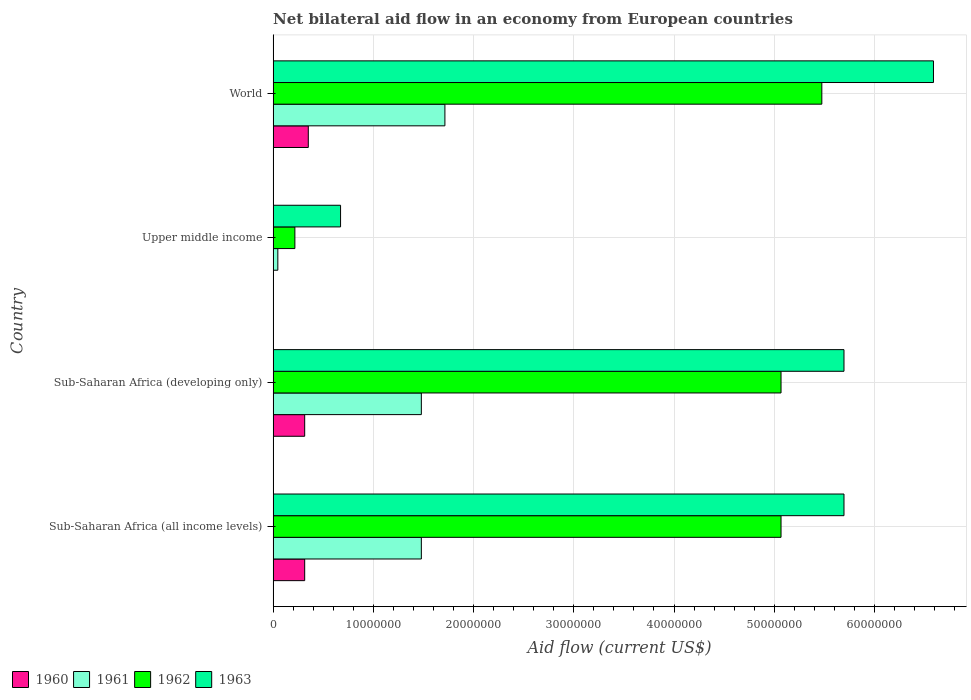How many different coloured bars are there?
Offer a very short reply. 4. Are the number of bars per tick equal to the number of legend labels?
Your answer should be compact. Yes. How many bars are there on the 4th tick from the bottom?
Provide a succinct answer. 4. What is the label of the 3rd group of bars from the top?
Ensure brevity in your answer.  Sub-Saharan Africa (developing only). In how many cases, is the number of bars for a given country not equal to the number of legend labels?
Provide a succinct answer. 0. What is the net bilateral aid flow in 1962 in World?
Give a very brief answer. 5.48e+07. Across all countries, what is the maximum net bilateral aid flow in 1961?
Make the answer very short. 1.71e+07. Across all countries, what is the minimum net bilateral aid flow in 1960?
Provide a short and direct response. 10000. In which country was the net bilateral aid flow in 1962 minimum?
Make the answer very short. Upper middle income. What is the total net bilateral aid flow in 1961 in the graph?
Make the answer very short. 4.72e+07. What is the difference between the net bilateral aid flow in 1961 in Sub-Saharan Africa (developing only) and that in World?
Make the answer very short. -2.35e+06. What is the difference between the net bilateral aid flow in 1963 in World and the net bilateral aid flow in 1961 in Upper middle income?
Your answer should be very brief. 6.54e+07. What is the average net bilateral aid flow in 1962 per country?
Give a very brief answer. 3.96e+07. What is the difference between the net bilateral aid flow in 1962 and net bilateral aid flow in 1960 in World?
Your answer should be very brief. 5.12e+07. What is the ratio of the net bilateral aid flow in 1963 in Sub-Saharan Africa (all income levels) to that in World?
Provide a succinct answer. 0.86. Is the difference between the net bilateral aid flow in 1962 in Sub-Saharan Africa (all income levels) and World greater than the difference between the net bilateral aid flow in 1960 in Sub-Saharan Africa (all income levels) and World?
Provide a short and direct response. No. What is the difference between the highest and the second highest net bilateral aid flow in 1962?
Make the answer very short. 4.07e+06. What is the difference between the highest and the lowest net bilateral aid flow in 1962?
Offer a very short reply. 5.26e+07. In how many countries, is the net bilateral aid flow in 1960 greater than the average net bilateral aid flow in 1960 taken over all countries?
Your answer should be very brief. 3. Is the sum of the net bilateral aid flow in 1961 in Sub-Saharan Africa (developing only) and World greater than the maximum net bilateral aid flow in 1963 across all countries?
Offer a terse response. No. What does the 2nd bar from the top in Sub-Saharan Africa (all income levels) represents?
Offer a terse response. 1962. What does the 3rd bar from the bottom in Sub-Saharan Africa (all income levels) represents?
Your answer should be compact. 1962. Are all the bars in the graph horizontal?
Give a very brief answer. Yes. How many countries are there in the graph?
Provide a short and direct response. 4. What is the difference between two consecutive major ticks on the X-axis?
Keep it short and to the point. 1.00e+07. Does the graph contain grids?
Offer a very short reply. Yes. How are the legend labels stacked?
Ensure brevity in your answer.  Horizontal. What is the title of the graph?
Your answer should be very brief. Net bilateral aid flow in an economy from European countries. Does "1996" appear as one of the legend labels in the graph?
Your answer should be compact. No. What is the Aid flow (current US$) of 1960 in Sub-Saharan Africa (all income levels)?
Your answer should be compact. 3.15e+06. What is the Aid flow (current US$) of 1961 in Sub-Saharan Africa (all income levels)?
Your answer should be very brief. 1.48e+07. What is the Aid flow (current US$) of 1962 in Sub-Saharan Africa (all income levels)?
Your answer should be very brief. 5.07e+07. What is the Aid flow (current US$) in 1963 in Sub-Saharan Africa (all income levels)?
Offer a terse response. 5.70e+07. What is the Aid flow (current US$) in 1960 in Sub-Saharan Africa (developing only)?
Your answer should be very brief. 3.15e+06. What is the Aid flow (current US$) in 1961 in Sub-Saharan Africa (developing only)?
Your answer should be very brief. 1.48e+07. What is the Aid flow (current US$) in 1962 in Sub-Saharan Africa (developing only)?
Provide a short and direct response. 5.07e+07. What is the Aid flow (current US$) of 1963 in Sub-Saharan Africa (developing only)?
Your answer should be very brief. 5.70e+07. What is the Aid flow (current US$) in 1962 in Upper middle income?
Keep it short and to the point. 2.17e+06. What is the Aid flow (current US$) of 1963 in Upper middle income?
Keep it short and to the point. 6.73e+06. What is the Aid flow (current US$) of 1960 in World?
Ensure brevity in your answer.  3.51e+06. What is the Aid flow (current US$) of 1961 in World?
Make the answer very short. 1.71e+07. What is the Aid flow (current US$) in 1962 in World?
Keep it short and to the point. 5.48e+07. What is the Aid flow (current US$) in 1963 in World?
Provide a short and direct response. 6.59e+07. Across all countries, what is the maximum Aid flow (current US$) of 1960?
Keep it short and to the point. 3.51e+06. Across all countries, what is the maximum Aid flow (current US$) in 1961?
Your response must be concise. 1.71e+07. Across all countries, what is the maximum Aid flow (current US$) in 1962?
Keep it short and to the point. 5.48e+07. Across all countries, what is the maximum Aid flow (current US$) of 1963?
Keep it short and to the point. 6.59e+07. Across all countries, what is the minimum Aid flow (current US$) in 1961?
Your response must be concise. 4.70e+05. Across all countries, what is the minimum Aid flow (current US$) in 1962?
Give a very brief answer. 2.17e+06. Across all countries, what is the minimum Aid flow (current US$) of 1963?
Your answer should be compact. 6.73e+06. What is the total Aid flow (current US$) in 1960 in the graph?
Your answer should be compact. 9.82e+06. What is the total Aid flow (current US$) in 1961 in the graph?
Give a very brief answer. 4.72e+07. What is the total Aid flow (current US$) of 1962 in the graph?
Offer a terse response. 1.58e+08. What is the total Aid flow (current US$) in 1963 in the graph?
Your answer should be very brief. 1.87e+08. What is the difference between the Aid flow (current US$) of 1960 in Sub-Saharan Africa (all income levels) and that in Sub-Saharan Africa (developing only)?
Provide a short and direct response. 0. What is the difference between the Aid flow (current US$) in 1961 in Sub-Saharan Africa (all income levels) and that in Sub-Saharan Africa (developing only)?
Keep it short and to the point. 0. What is the difference between the Aid flow (current US$) of 1963 in Sub-Saharan Africa (all income levels) and that in Sub-Saharan Africa (developing only)?
Your answer should be very brief. 0. What is the difference between the Aid flow (current US$) in 1960 in Sub-Saharan Africa (all income levels) and that in Upper middle income?
Give a very brief answer. 3.14e+06. What is the difference between the Aid flow (current US$) of 1961 in Sub-Saharan Africa (all income levels) and that in Upper middle income?
Make the answer very short. 1.43e+07. What is the difference between the Aid flow (current US$) in 1962 in Sub-Saharan Africa (all income levels) and that in Upper middle income?
Give a very brief answer. 4.85e+07. What is the difference between the Aid flow (current US$) of 1963 in Sub-Saharan Africa (all income levels) and that in Upper middle income?
Offer a very short reply. 5.02e+07. What is the difference between the Aid flow (current US$) of 1960 in Sub-Saharan Africa (all income levels) and that in World?
Your answer should be compact. -3.60e+05. What is the difference between the Aid flow (current US$) of 1961 in Sub-Saharan Africa (all income levels) and that in World?
Keep it short and to the point. -2.35e+06. What is the difference between the Aid flow (current US$) of 1962 in Sub-Saharan Africa (all income levels) and that in World?
Ensure brevity in your answer.  -4.07e+06. What is the difference between the Aid flow (current US$) of 1963 in Sub-Saharan Africa (all income levels) and that in World?
Give a very brief answer. -8.93e+06. What is the difference between the Aid flow (current US$) of 1960 in Sub-Saharan Africa (developing only) and that in Upper middle income?
Provide a succinct answer. 3.14e+06. What is the difference between the Aid flow (current US$) in 1961 in Sub-Saharan Africa (developing only) and that in Upper middle income?
Your answer should be very brief. 1.43e+07. What is the difference between the Aid flow (current US$) of 1962 in Sub-Saharan Africa (developing only) and that in Upper middle income?
Offer a terse response. 4.85e+07. What is the difference between the Aid flow (current US$) of 1963 in Sub-Saharan Africa (developing only) and that in Upper middle income?
Your answer should be very brief. 5.02e+07. What is the difference between the Aid flow (current US$) of 1960 in Sub-Saharan Africa (developing only) and that in World?
Keep it short and to the point. -3.60e+05. What is the difference between the Aid flow (current US$) of 1961 in Sub-Saharan Africa (developing only) and that in World?
Your response must be concise. -2.35e+06. What is the difference between the Aid flow (current US$) in 1962 in Sub-Saharan Africa (developing only) and that in World?
Your answer should be compact. -4.07e+06. What is the difference between the Aid flow (current US$) of 1963 in Sub-Saharan Africa (developing only) and that in World?
Your answer should be very brief. -8.93e+06. What is the difference between the Aid flow (current US$) in 1960 in Upper middle income and that in World?
Provide a short and direct response. -3.50e+06. What is the difference between the Aid flow (current US$) of 1961 in Upper middle income and that in World?
Offer a terse response. -1.67e+07. What is the difference between the Aid flow (current US$) in 1962 in Upper middle income and that in World?
Ensure brevity in your answer.  -5.26e+07. What is the difference between the Aid flow (current US$) of 1963 in Upper middle income and that in World?
Provide a short and direct response. -5.92e+07. What is the difference between the Aid flow (current US$) of 1960 in Sub-Saharan Africa (all income levels) and the Aid flow (current US$) of 1961 in Sub-Saharan Africa (developing only)?
Provide a succinct answer. -1.16e+07. What is the difference between the Aid flow (current US$) of 1960 in Sub-Saharan Africa (all income levels) and the Aid flow (current US$) of 1962 in Sub-Saharan Africa (developing only)?
Ensure brevity in your answer.  -4.75e+07. What is the difference between the Aid flow (current US$) of 1960 in Sub-Saharan Africa (all income levels) and the Aid flow (current US$) of 1963 in Sub-Saharan Africa (developing only)?
Your answer should be very brief. -5.38e+07. What is the difference between the Aid flow (current US$) of 1961 in Sub-Saharan Africa (all income levels) and the Aid flow (current US$) of 1962 in Sub-Saharan Africa (developing only)?
Make the answer very short. -3.59e+07. What is the difference between the Aid flow (current US$) of 1961 in Sub-Saharan Africa (all income levels) and the Aid flow (current US$) of 1963 in Sub-Saharan Africa (developing only)?
Give a very brief answer. -4.22e+07. What is the difference between the Aid flow (current US$) in 1962 in Sub-Saharan Africa (all income levels) and the Aid flow (current US$) in 1963 in Sub-Saharan Africa (developing only)?
Provide a short and direct response. -6.28e+06. What is the difference between the Aid flow (current US$) in 1960 in Sub-Saharan Africa (all income levels) and the Aid flow (current US$) in 1961 in Upper middle income?
Offer a very short reply. 2.68e+06. What is the difference between the Aid flow (current US$) in 1960 in Sub-Saharan Africa (all income levels) and the Aid flow (current US$) in 1962 in Upper middle income?
Your answer should be very brief. 9.80e+05. What is the difference between the Aid flow (current US$) in 1960 in Sub-Saharan Africa (all income levels) and the Aid flow (current US$) in 1963 in Upper middle income?
Offer a terse response. -3.58e+06. What is the difference between the Aid flow (current US$) in 1961 in Sub-Saharan Africa (all income levels) and the Aid flow (current US$) in 1962 in Upper middle income?
Your answer should be compact. 1.26e+07. What is the difference between the Aid flow (current US$) in 1961 in Sub-Saharan Africa (all income levels) and the Aid flow (current US$) in 1963 in Upper middle income?
Give a very brief answer. 8.06e+06. What is the difference between the Aid flow (current US$) of 1962 in Sub-Saharan Africa (all income levels) and the Aid flow (current US$) of 1963 in Upper middle income?
Your answer should be compact. 4.40e+07. What is the difference between the Aid flow (current US$) in 1960 in Sub-Saharan Africa (all income levels) and the Aid flow (current US$) in 1961 in World?
Keep it short and to the point. -1.40e+07. What is the difference between the Aid flow (current US$) of 1960 in Sub-Saharan Africa (all income levels) and the Aid flow (current US$) of 1962 in World?
Provide a succinct answer. -5.16e+07. What is the difference between the Aid flow (current US$) in 1960 in Sub-Saharan Africa (all income levels) and the Aid flow (current US$) in 1963 in World?
Make the answer very short. -6.27e+07. What is the difference between the Aid flow (current US$) in 1961 in Sub-Saharan Africa (all income levels) and the Aid flow (current US$) in 1962 in World?
Give a very brief answer. -4.00e+07. What is the difference between the Aid flow (current US$) of 1961 in Sub-Saharan Africa (all income levels) and the Aid flow (current US$) of 1963 in World?
Provide a succinct answer. -5.11e+07. What is the difference between the Aid flow (current US$) in 1962 in Sub-Saharan Africa (all income levels) and the Aid flow (current US$) in 1963 in World?
Provide a succinct answer. -1.52e+07. What is the difference between the Aid flow (current US$) of 1960 in Sub-Saharan Africa (developing only) and the Aid flow (current US$) of 1961 in Upper middle income?
Ensure brevity in your answer.  2.68e+06. What is the difference between the Aid flow (current US$) in 1960 in Sub-Saharan Africa (developing only) and the Aid flow (current US$) in 1962 in Upper middle income?
Your response must be concise. 9.80e+05. What is the difference between the Aid flow (current US$) in 1960 in Sub-Saharan Africa (developing only) and the Aid flow (current US$) in 1963 in Upper middle income?
Make the answer very short. -3.58e+06. What is the difference between the Aid flow (current US$) in 1961 in Sub-Saharan Africa (developing only) and the Aid flow (current US$) in 1962 in Upper middle income?
Your answer should be compact. 1.26e+07. What is the difference between the Aid flow (current US$) in 1961 in Sub-Saharan Africa (developing only) and the Aid flow (current US$) in 1963 in Upper middle income?
Your answer should be very brief. 8.06e+06. What is the difference between the Aid flow (current US$) of 1962 in Sub-Saharan Africa (developing only) and the Aid flow (current US$) of 1963 in Upper middle income?
Provide a succinct answer. 4.40e+07. What is the difference between the Aid flow (current US$) in 1960 in Sub-Saharan Africa (developing only) and the Aid flow (current US$) in 1961 in World?
Make the answer very short. -1.40e+07. What is the difference between the Aid flow (current US$) of 1960 in Sub-Saharan Africa (developing only) and the Aid flow (current US$) of 1962 in World?
Offer a very short reply. -5.16e+07. What is the difference between the Aid flow (current US$) of 1960 in Sub-Saharan Africa (developing only) and the Aid flow (current US$) of 1963 in World?
Provide a succinct answer. -6.27e+07. What is the difference between the Aid flow (current US$) in 1961 in Sub-Saharan Africa (developing only) and the Aid flow (current US$) in 1962 in World?
Make the answer very short. -4.00e+07. What is the difference between the Aid flow (current US$) in 1961 in Sub-Saharan Africa (developing only) and the Aid flow (current US$) in 1963 in World?
Ensure brevity in your answer.  -5.11e+07. What is the difference between the Aid flow (current US$) in 1962 in Sub-Saharan Africa (developing only) and the Aid flow (current US$) in 1963 in World?
Offer a very short reply. -1.52e+07. What is the difference between the Aid flow (current US$) of 1960 in Upper middle income and the Aid flow (current US$) of 1961 in World?
Your response must be concise. -1.71e+07. What is the difference between the Aid flow (current US$) in 1960 in Upper middle income and the Aid flow (current US$) in 1962 in World?
Provide a succinct answer. -5.47e+07. What is the difference between the Aid flow (current US$) in 1960 in Upper middle income and the Aid flow (current US$) in 1963 in World?
Ensure brevity in your answer.  -6.59e+07. What is the difference between the Aid flow (current US$) of 1961 in Upper middle income and the Aid flow (current US$) of 1962 in World?
Your response must be concise. -5.43e+07. What is the difference between the Aid flow (current US$) in 1961 in Upper middle income and the Aid flow (current US$) in 1963 in World?
Keep it short and to the point. -6.54e+07. What is the difference between the Aid flow (current US$) of 1962 in Upper middle income and the Aid flow (current US$) of 1963 in World?
Your answer should be compact. -6.37e+07. What is the average Aid flow (current US$) of 1960 per country?
Offer a very short reply. 2.46e+06. What is the average Aid flow (current US$) in 1961 per country?
Your answer should be compact. 1.18e+07. What is the average Aid flow (current US$) in 1962 per country?
Provide a short and direct response. 3.96e+07. What is the average Aid flow (current US$) in 1963 per country?
Provide a succinct answer. 4.66e+07. What is the difference between the Aid flow (current US$) of 1960 and Aid flow (current US$) of 1961 in Sub-Saharan Africa (all income levels)?
Provide a short and direct response. -1.16e+07. What is the difference between the Aid flow (current US$) in 1960 and Aid flow (current US$) in 1962 in Sub-Saharan Africa (all income levels)?
Provide a short and direct response. -4.75e+07. What is the difference between the Aid flow (current US$) in 1960 and Aid flow (current US$) in 1963 in Sub-Saharan Africa (all income levels)?
Offer a terse response. -5.38e+07. What is the difference between the Aid flow (current US$) in 1961 and Aid flow (current US$) in 1962 in Sub-Saharan Africa (all income levels)?
Ensure brevity in your answer.  -3.59e+07. What is the difference between the Aid flow (current US$) of 1961 and Aid flow (current US$) of 1963 in Sub-Saharan Africa (all income levels)?
Your answer should be compact. -4.22e+07. What is the difference between the Aid flow (current US$) in 1962 and Aid flow (current US$) in 1963 in Sub-Saharan Africa (all income levels)?
Ensure brevity in your answer.  -6.28e+06. What is the difference between the Aid flow (current US$) of 1960 and Aid flow (current US$) of 1961 in Sub-Saharan Africa (developing only)?
Offer a very short reply. -1.16e+07. What is the difference between the Aid flow (current US$) in 1960 and Aid flow (current US$) in 1962 in Sub-Saharan Africa (developing only)?
Offer a terse response. -4.75e+07. What is the difference between the Aid flow (current US$) of 1960 and Aid flow (current US$) of 1963 in Sub-Saharan Africa (developing only)?
Offer a very short reply. -5.38e+07. What is the difference between the Aid flow (current US$) of 1961 and Aid flow (current US$) of 1962 in Sub-Saharan Africa (developing only)?
Make the answer very short. -3.59e+07. What is the difference between the Aid flow (current US$) of 1961 and Aid flow (current US$) of 1963 in Sub-Saharan Africa (developing only)?
Offer a terse response. -4.22e+07. What is the difference between the Aid flow (current US$) of 1962 and Aid flow (current US$) of 1963 in Sub-Saharan Africa (developing only)?
Offer a very short reply. -6.28e+06. What is the difference between the Aid flow (current US$) of 1960 and Aid flow (current US$) of 1961 in Upper middle income?
Ensure brevity in your answer.  -4.60e+05. What is the difference between the Aid flow (current US$) of 1960 and Aid flow (current US$) of 1962 in Upper middle income?
Make the answer very short. -2.16e+06. What is the difference between the Aid flow (current US$) of 1960 and Aid flow (current US$) of 1963 in Upper middle income?
Your response must be concise. -6.72e+06. What is the difference between the Aid flow (current US$) of 1961 and Aid flow (current US$) of 1962 in Upper middle income?
Ensure brevity in your answer.  -1.70e+06. What is the difference between the Aid flow (current US$) in 1961 and Aid flow (current US$) in 1963 in Upper middle income?
Keep it short and to the point. -6.26e+06. What is the difference between the Aid flow (current US$) of 1962 and Aid flow (current US$) of 1963 in Upper middle income?
Ensure brevity in your answer.  -4.56e+06. What is the difference between the Aid flow (current US$) of 1960 and Aid flow (current US$) of 1961 in World?
Provide a succinct answer. -1.36e+07. What is the difference between the Aid flow (current US$) in 1960 and Aid flow (current US$) in 1962 in World?
Provide a short and direct response. -5.12e+07. What is the difference between the Aid flow (current US$) of 1960 and Aid flow (current US$) of 1963 in World?
Make the answer very short. -6.24e+07. What is the difference between the Aid flow (current US$) in 1961 and Aid flow (current US$) in 1962 in World?
Offer a terse response. -3.76e+07. What is the difference between the Aid flow (current US$) of 1961 and Aid flow (current US$) of 1963 in World?
Your answer should be compact. -4.88e+07. What is the difference between the Aid flow (current US$) in 1962 and Aid flow (current US$) in 1963 in World?
Keep it short and to the point. -1.11e+07. What is the ratio of the Aid flow (current US$) in 1960 in Sub-Saharan Africa (all income levels) to that in Sub-Saharan Africa (developing only)?
Provide a short and direct response. 1. What is the ratio of the Aid flow (current US$) of 1961 in Sub-Saharan Africa (all income levels) to that in Sub-Saharan Africa (developing only)?
Make the answer very short. 1. What is the ratio of the Aid flow (current US$) of 1963 in Sub-Saharan Africa (all income levels) to that in Sub-Saharan Africa (developing only)?
Give a very brief answer. 1. What is the ratio of the Aid flow (current US$) in 1960 in Sub-Saharan Africa (all income levels) to that in Upper middle income?
Make the answer very short. 315. What is the ratio of the Aid flow (current US$) of 1961 in Sub-Saharan Africa (all income levels) to that in Upper middle income?
Your answer should be very brief. 31.47. What is the ratio of the Aid flow (current US$) in 1962 in Sub-Saharan Africa (all income levels) to that in Upper middle income?
Your answer should be compact. 23.35. What is the ratio of the Aid flow (current US$) in 1963 in Sub-Saharan Africa (all income levels) to that in Upper middle income?
Your answer should be compact. 8.46. What is the ratio of the Aid flow (current US$) of 1960 in Sub-Saharan Africa (all income levels) to that in World?
Offer a terse response. 0.9. What is the ratio of the Aid flow (current US$) in 1961 in Sub-Saharan Africa (all income levels) to that in World?
Ensure brevity in your answer.  0.86. What is the ratio of the Aid flow (current US$) of 1962 in Sub-Saharan Africa (all income levels) to that in World?
Your response must be concise. 0.93. What is the ratio of the Aid flow (current US$) in 1963 in Sub-Saharan Africa (all income levels) to that in World?
Make the answer very short. 0.86. What is the ratio of the Aid flow (current US$) in 1960 in Sub-Saharan Africa (developing only) to that in Upper middle income?
Provide a short and direct response. 315. What is the ratio of the Aid flow (current US$) in 1961 in Sub-Saharan Africa (developing only) to that in Upper middle income?
Provide a short and direct response. 31.47. What is the ratio of the Aid flow (current US$) of 1962 in Sub-Saharan Africa (developing only) to that in Upper middle income?
Offer a terse response. 23.35. What is the ratio of the Aid flow (current US$) in 1963 in Sub-Saharan Africa (developing only) to that in Upper middle income?
Provide a short and direct response. 8.46. What is the ratio of the Aid flow (current US$) in 1960 in Sub-Saharan Africa (developing only) to that in World?
Ensure brevity in your answer.  0.9. What is the ratio of the Aid flow (current US$) of 1961 in Sub-Saharan Africa (developing only) to that in World?
Ensure brevity in your answer.  0.86. What is the ratio of the Aid flow (current US$) in 1962 in Sub-Saharan Africa (developing only) to that in World?
Give a very brief answer. 0.93. What is the ratio of the Aid flow (current US$) of 1963 in Sub-Saharan Africa (developing only) to that in World?
Your answer should be compact. 0.86. What is the ratio of the Aid flow (current US$) in 1960 in Upper middle income to that in World?
Your answer should be very brief. 0. What is the ratio of the Aid flow (current US$) of 1961 in Upper middle income to that in World?
Your answer should be very brief. 0.03. What is the ratio of the Aid flow (current US$) in 1962 in Upper middle income to that in World?
Ensure brevity in your answer.  0.04. What is the ratio of the Aid flow (current US$) in 1963 in Upper middle income to that in World?
Make the answer very short. 0.1. What is the difference between the highest and the second highest Aid flow (current US$) of 1961?
Keep it short and to the point. 2.35e+06. What is the difference between the highest and the second highest Aid flow (current US$) of 1962?
Make the answer very short. 4.07e+06. What is the difference between the highest and the second highest Aid flow (current US$) of 1963?
Offer a very short reply. 8.93e+06. What is the difference between the highest and the lowest Aid flow (current US$) in 1960?
Ensure brevity in your answer.  3.50e+06. What is the difference between the highest and the lowest Aid flow (current US$) in 1961?
Provide a short and direct response. 1.67e+07. What is the difference between the highest and the lowest Aid flow (current US$) of 1962?
Your answer should be very brief. 5.26e+07. What is the difference between the highest and the lowest Aid flow (current US$) in 1963?
Offer a very short reply. 5.92e+07. 